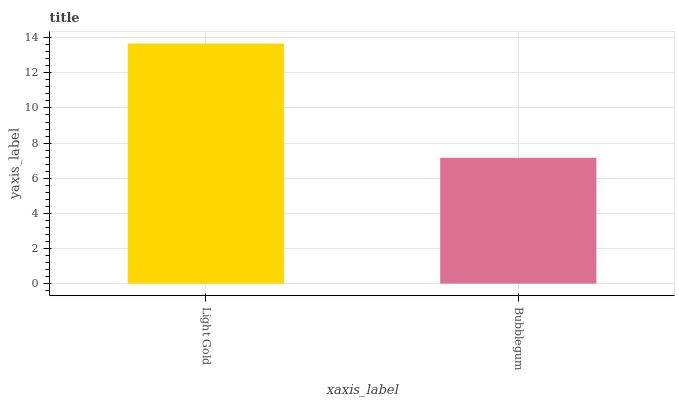Is Bubblegum the minimum?
Answer yes or no. Yes. Is Light Gold the maximum?
Answer yes or no. Yes. Is Bubblegum the maximum?
Answer yes or no. No. Is Light Gold greater than Bubblegum?
Answer yes or no. Yes. Is Bubblegum less than Light Gold?
Answer yes or no. Yes. Is Bubblegum greater than Light Gold?
Answer yes or no. No. Is Light Gold less than Bubblegum?
Answer yes or no. No. Is Light Gold the high median?
Answer yes or no. Yes. Is Bubblegum the low median?
Answer yes or no. Yes. Is Bubblegum the high median?
Answer yes or no. No. Is Light Gold the low median?
Answer yes or no. No. 